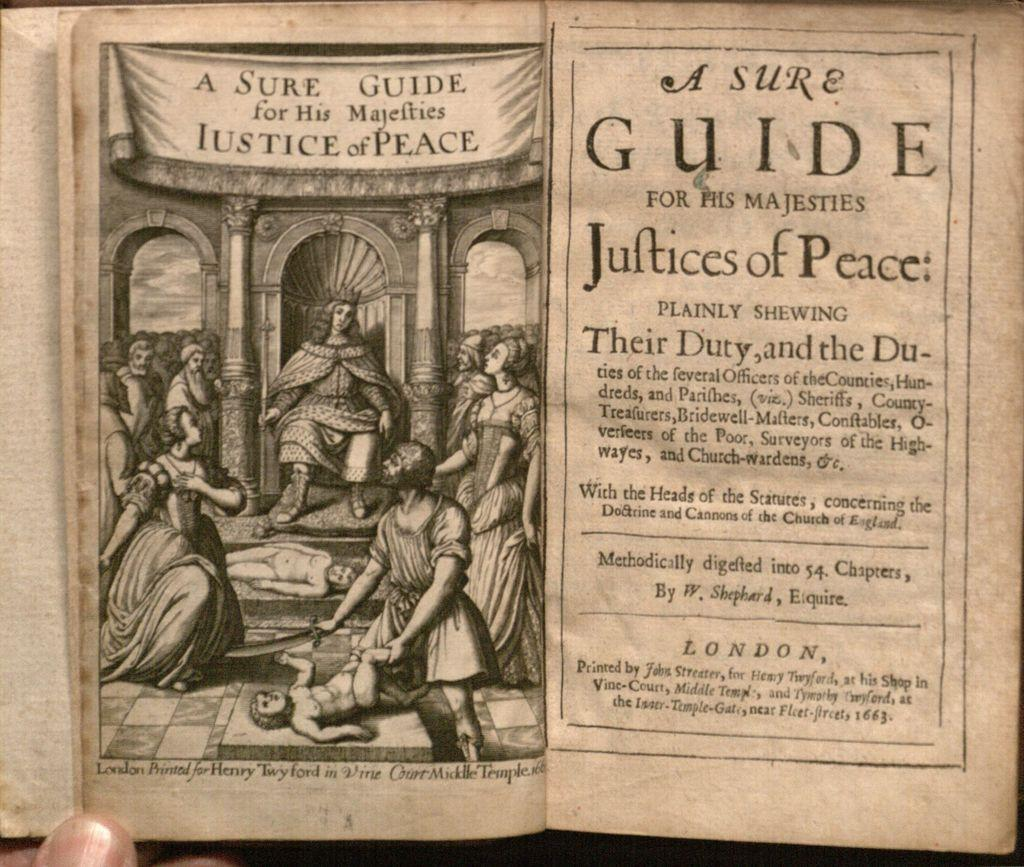<image>
Relay a brief, clear account of the picture shown. The title page of a book that was printed in London in 1663. 